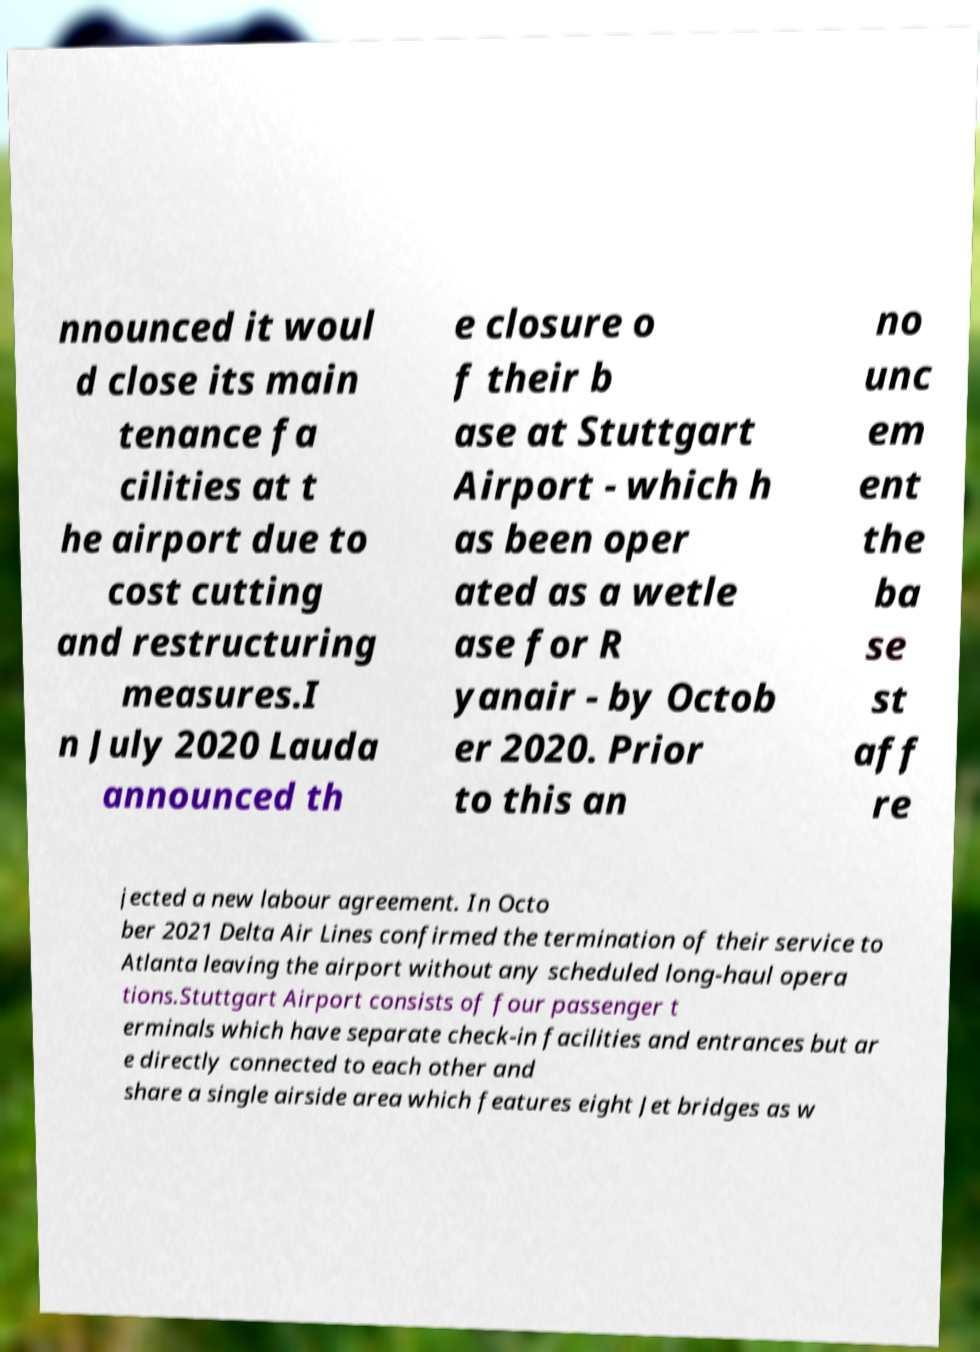What messages or text are displayed in this image? I need them in a readable, typed format. nnounced it woul d close its main tenance fa cilities at t he airport due to cost cutting and restructuring measures.I n July 2020 Lauda announced th e closure o f their b ase at Stuttgart Airport - which h as been oper ated as a wetle ase for R yanair - by Octob er 2020. Prior to this an no unc em ent the ba se st aff re jected a new labour agreement. In Octo ber 2021 Delta Air Lines confirmed the termination of their service to Atlanta leaving the airport without any scheduled long-haul opera tions.Stuttgart Airport consists of four passenger t erminals which have separate check-in facilities and entrances but ar e directly connected to each other and share a single airside area which features eight Jet bridges as w 